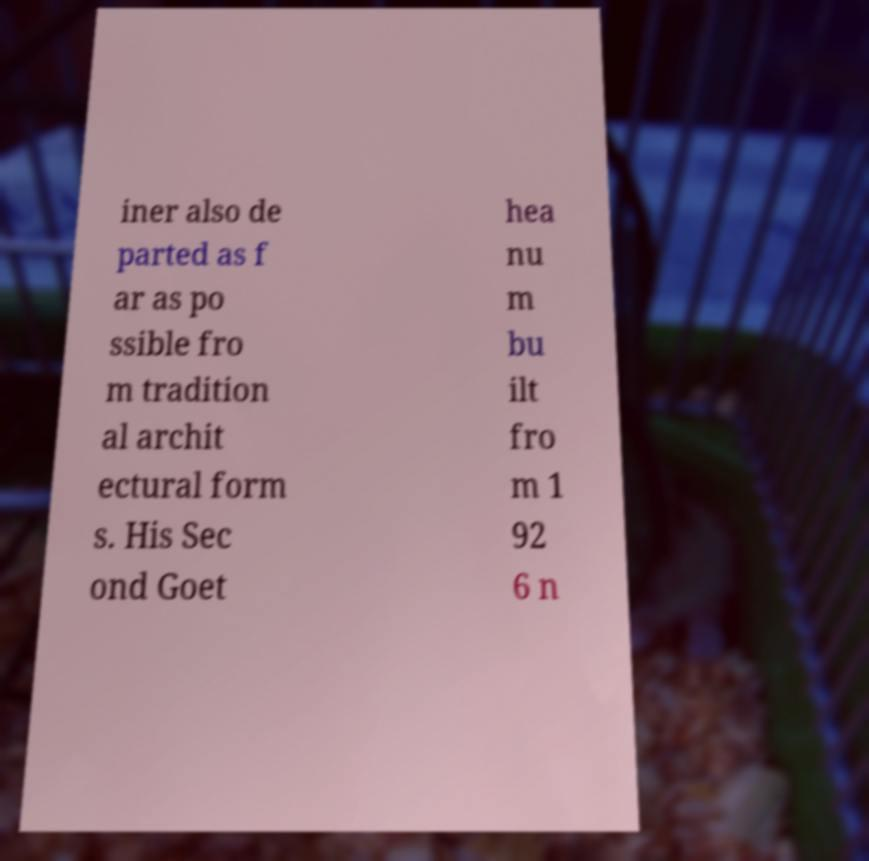Can you accurately transcribe the text from the provided image for me? iner also de parted as f ar as po ssible fro m tradition al archit ectural form s. His Sec ond Goet hea nu m bu ilt fro m 1 92 6 n 